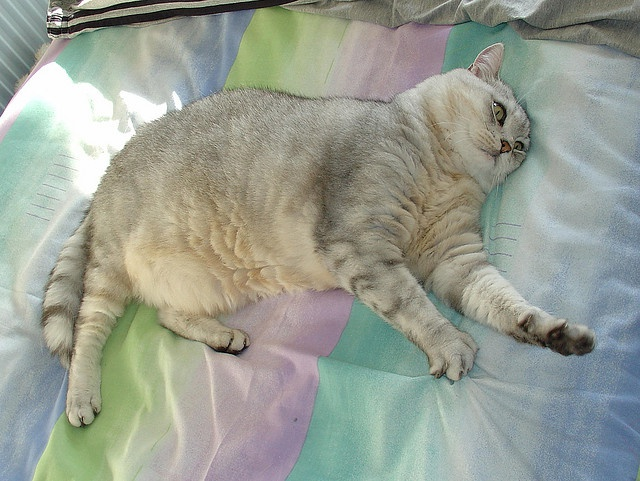Describe the objects in this image and their specific colors. I can see bed in darkgray, gray, and ivory tones and cat in darkgray and gray tones in this image. 